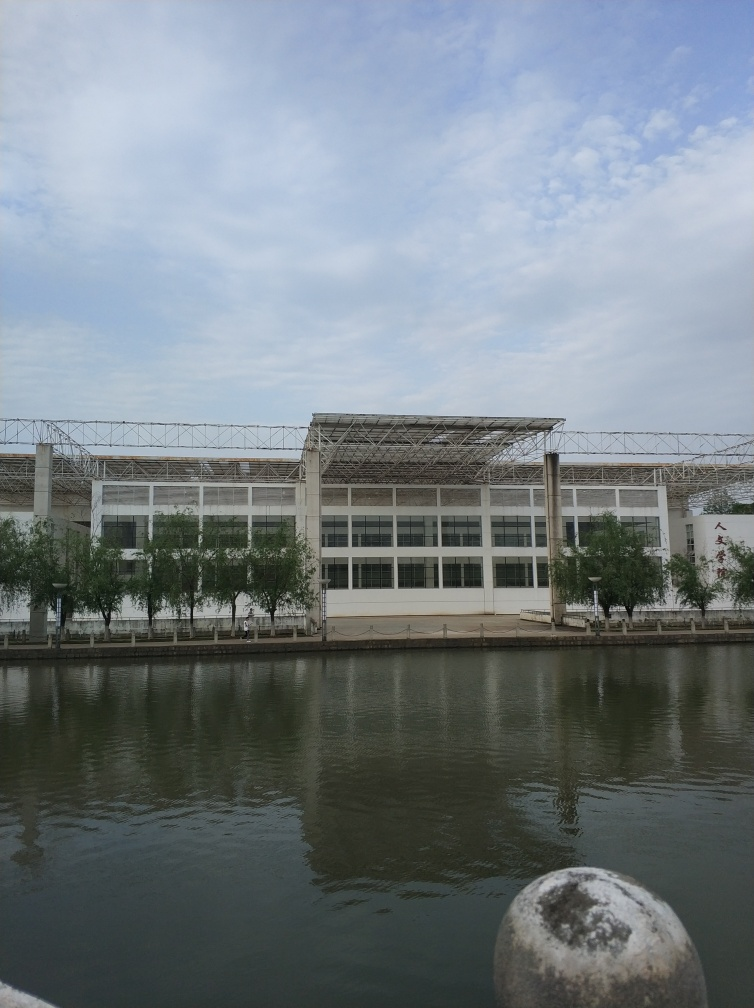Is the area surrounding the water body well-maintained? Yes, the area surrounding the water body appears to be well-maintained. The cleanliness of the water surface, clear delineation of the waterside path, and the manicured appearance of the vegetation reflect a certain level of care and upkeep in the environment. 